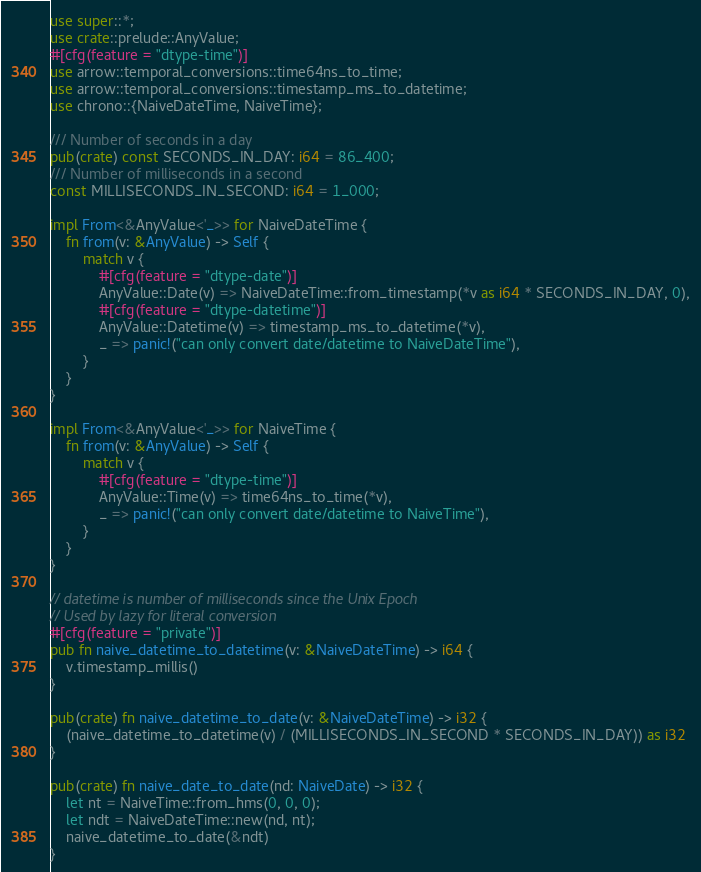<code> <loc_0><loc_0><loc_500><loc_500><_Rust_>use super::*;
use crate::prelude::AnyValue;
#[cfg(feature = "dtype-time")]
use arrow::temporal_conversions::time64ns_to_time;
use arrow::temporal_conversions::timestamp_ms_to_datetime;
use chrono::{NaiveDateTime, NaiveTime};

/// Number of seconds in a day
pub(crate) const SECONDS_IN_DAY: i64 = 86_400;
/// Number of milliseconds in a second
const MILLISECONDS_IN_SECOND: i64 = 1_000;

impl From<&AnyValue<'_>> for NaiveDateTime {
    fn from(v: &AnyValue) -> Self {
        match v {
            #[cfg(feature = "dtype-date")]
            AnyValue::Date(v) => NaiveDateTime::from_timestamp(*v as i64 * SECONDS_IN_DAY, 0),
            #[cfg(feature = "dtype-datetime")]
            AnyValue::Datetime(v) => timestamp_ms_to_datetime(*v),
            _ => panic!("can only convert date/datetime to NaiveDateTime"),
        }
    }
}

impl From<&AnyValue<'_>> for NaiveTime {
    fn from(v: &AnyValue) -> Self {
        match v {
            #[cfg(feature = "dtype-time")]
            AnyValue::Time(v) => time64ns_to_time(*v),
            _ => panic!("can only convert date/datetime to NaiveTime"),
        }
    }
}

// datetime is number of milliseconds since the Unix Epoch
// Used by lazy for literal conversion
#[cfg(feature = "private")]
pub fn naive_datetime_to_datetime(v: &NaiveDateTime) -> i64 {
    v.timestamp_millis()
}

pub(crate) fn naive_datetime_to_date(v: &NaiveDateTime) -> i32 {
    (naive_datetime_to_datetime(v) / (MILLISECONDS_IN_SECOND * SECONDS_IN_DAY)) as i32
}

pub(crate) fn naive_date_to_date(nd: NaiveDate) -> i32 {
    let nt = NaiveTime::from_hms(0, 0, 0);
    let ndt = NaiveDateTime::new(nd, nt);
    naive_datetime_to_date(&ndt)
}
</code> 